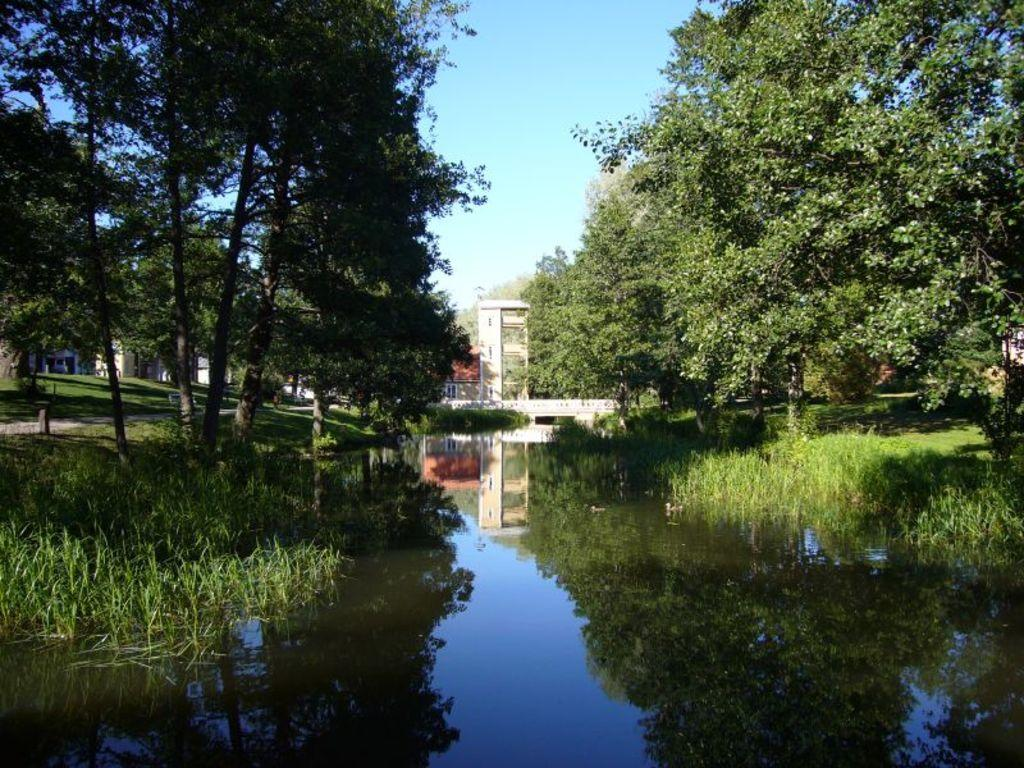What body of water is present in the image? There is a lake in the image. What type of vegetation is near the lake? There are trees beside the lake. What structures can be seen behind the lake? There are buildings behind the lake. What type of fuel is being used by the crib in the image? There is no crib present in the image, and therefore no fuel usage can be observed. 